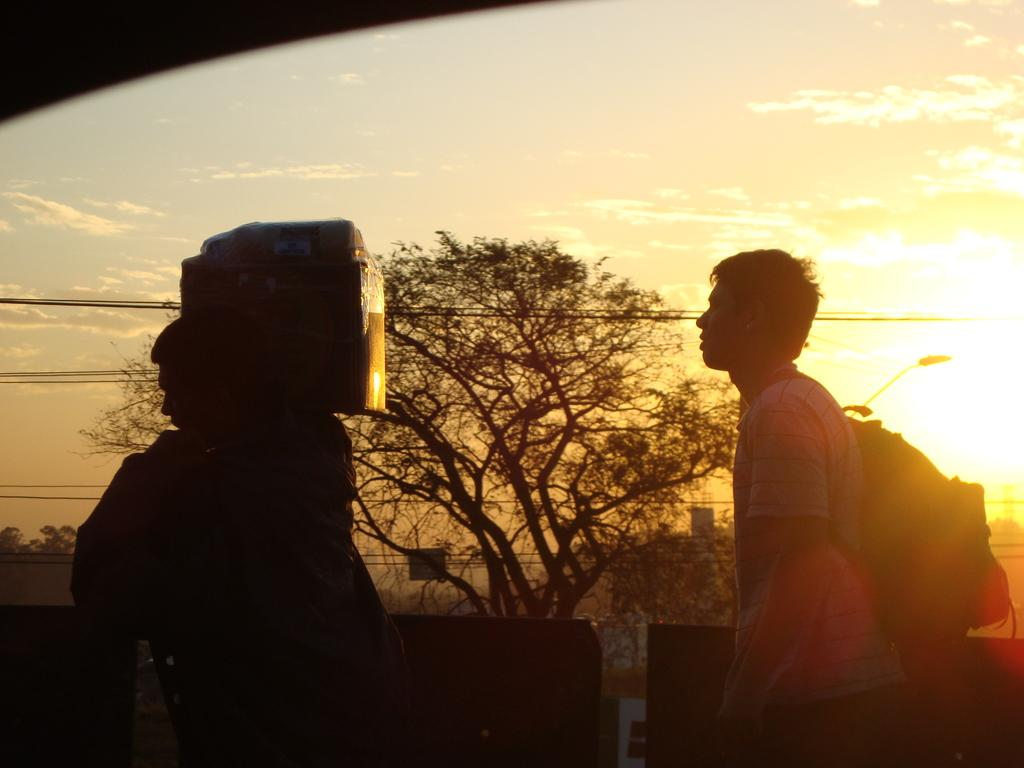How many people are in the image? There are two people in the image. What can be seen in the image besides the people? There is a bag, a box, walls, trees, wires, and some objects in the image. What is visible in the background of the image? The sky is visible in the background of the image. How many snakes are slithering on the wires in the image? There are no snakes present in the image; only wires can be seen. Can you tell me how the objects in the image are stretching? The objects in the image are not stretching; they are stationary. 